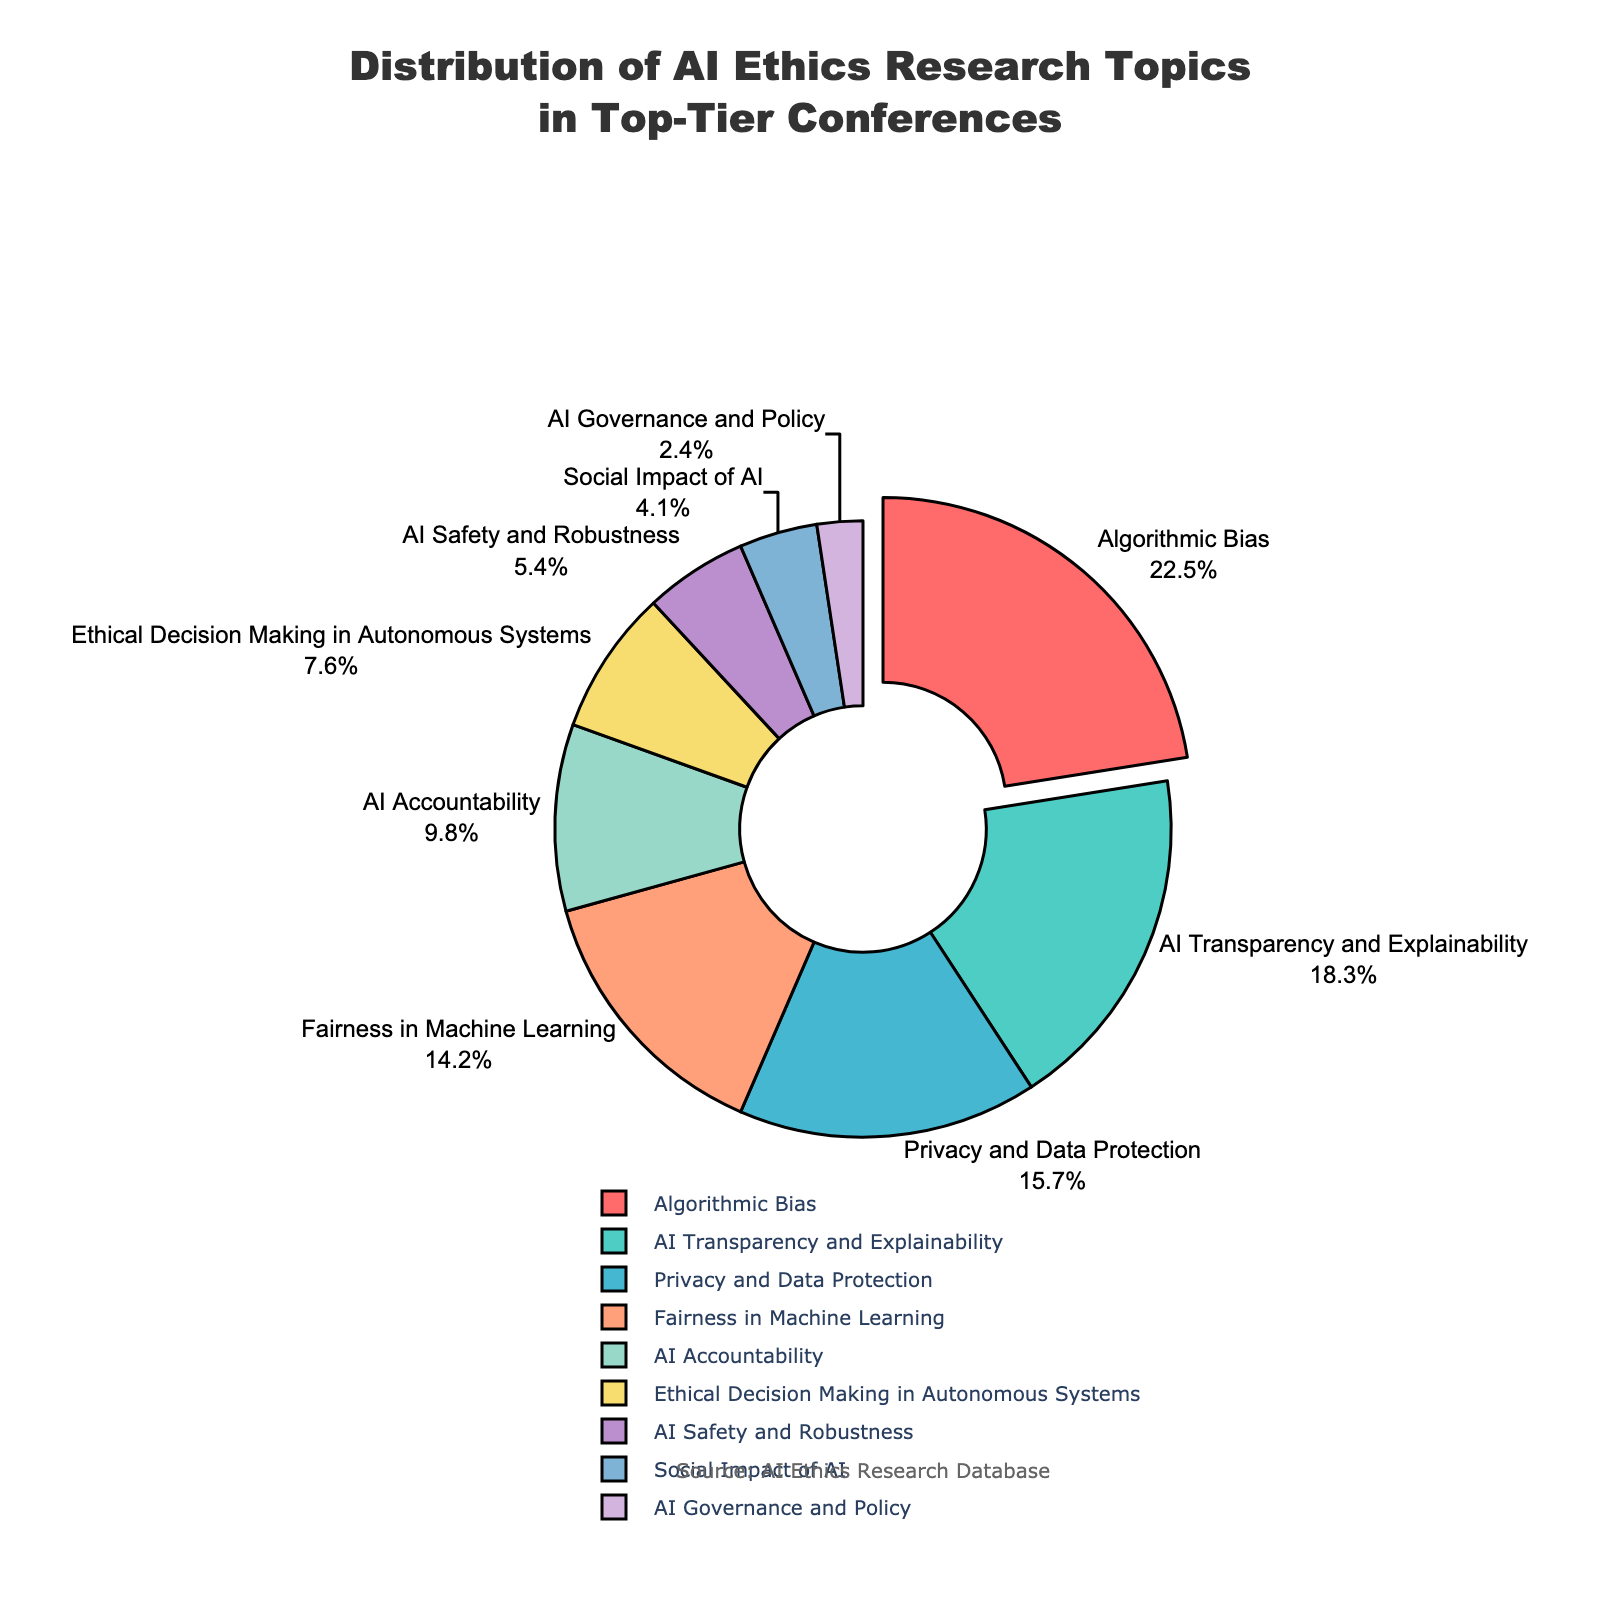What is the most researched topic in AI ethics according to the pie chart? The topic with the largest percentage in the pie chart indicates the most researched topic in AI ethics. Here, "Algorithmic Bias" occupies the largest sector.
Answer: Algorithmic Bias What percentage of AI ethics research topics is covered by "AI Transparency and Explainability" and "Privacy and Data Protection" combined? Sum the percentages of "AI Transparency and Explainability" (18.3%) and "Privacy and Data Protection" (15.7%). 18.3 + 15.7 = 34
Answer: 34% Which topic has a smaller percentage, "AI Safety and Robustness" or "Social Impact of AI"? Compare the percentages of "AI Safety and Robustness" (5.4%) and "Social Impact of AI" (4.1%). Since 4.1% < 5.4%, "Social Impact of AI" has a smaller percentage.
Answer: Social Impact of AI What is the difference in percentage between "Fairness in Machine Learning" and "Ethical Decision Making in Autonomous Systems"? Subtract the percentage of "Ethical Decision Making in Autonomous Systems" (7.6%) from "Fairness in Machine Learning" (14.2%). 14.2 - 7.6 = 6.6
Answer: 6.6% What color represents the "Algorithmic Bias" topic in the pie chart? Identify the color corresponding to the largest sector or the one slightly pulled out. "Algorithmic Bias" is represented by the bright red color.
Answer: Red How many topics have a percentage greater than 10%? Count the topics with a percentage greater than 10%: "Algorithmic Bias", "AI Transparency and Explainability", "Privacy and Data Protection", and "Fairness in Machine Learning".
Answer: 4 What is the average percentage of the topics related to "AI Accountability" and "AI Governance and Policy"? Calculate the average of the percentages of "AI Accountability" (9.8%) and "AI Governance and Policy" (2.4%). (9.8 + 2.4) / 2 = 6.1
Answer: 6.1% Which topic is closer in research percentage to "AI Safety and Robustness": "Social Impact of AI" or "AI Governance and Policy"? Compare the absolute differences between "AI Safety and Robustness" (5.4%) with "Social Impact of AI" (4.1%) and "AI Governance and Policy" (2.4%). 5.4 - 4.1 = 1.3 and 5.4 - 2.4 = 3.0, so "Social Impact of AI" is closer.
Answer: Social Impact of AI What percentage of the topics occupy less than or equal to 10% each? Identify topics with a percentage less than or equal to 10%: "AI Accountability" (9.8%), "Ethical Decision Making in Autonomous Systems" (7.6%), "AI Safety and Robustness" (5.4%), "Social Impact of AI" (4.1%), and "AI Governance and Policy" (2.4%). Add these percentages: (9.8 + 7.6 + 5.4 + 4.1 + 2.4) = 29.3
Answer: 29.3% Which three topics combined form the smallest portion of AI ethics research, and what is their combined percentage? The three smallest topics are: "AI Governance and Policy" (2.4%), "Social Impact of AI" (4.1%), "AI Safety and Robustness" (5.4%). Add these percentages: (2.4 + 4.1 + 5.4) = 11.9
Answer: AI Governance and Policy, Social Impact of AI, AI Safety and Robustness - 11.9% 